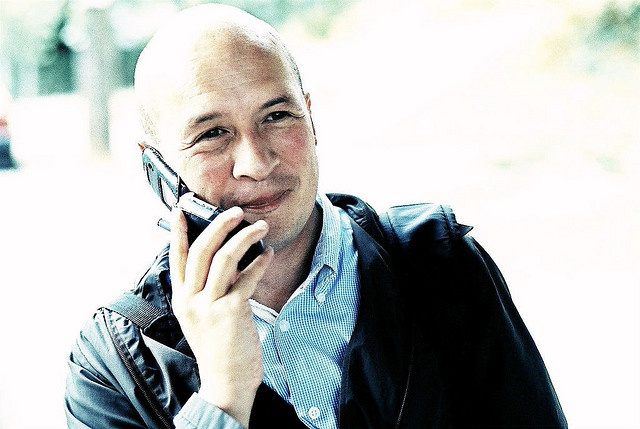Describe the objects in this image and their specific colors. I can see people in ivory, black, white, darkgray, and tan tones and cell phone in ivory, white, black, lightblue, and darkgray tones in this image. 